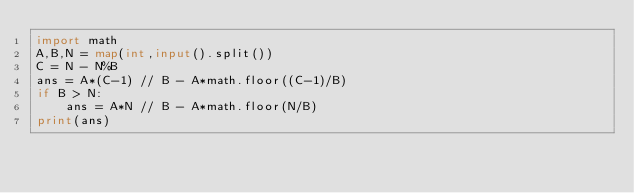Convert code to text. <code><loc_0><loc_0><loc_500><loc_500><_Python_>import math
A,B,N = map(int,input().split())
C = N - N%B
ans = A*(C-1) // B - A*math.floor((C-1)/B)
if B > N:
    ans = A*N // B - A*math.floor(N/B)
print(ans)</code> 